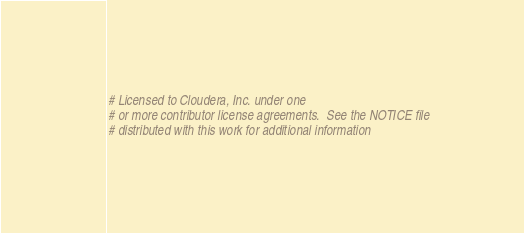Convert code to text. <code><loc_0><loc_0><loc_500><loc_500><_Python_># Licensed to Cloudera, Inc. under one
# or more contributor license agreements.  See the NOTICE file
# distributed with this work for additional information</code> 